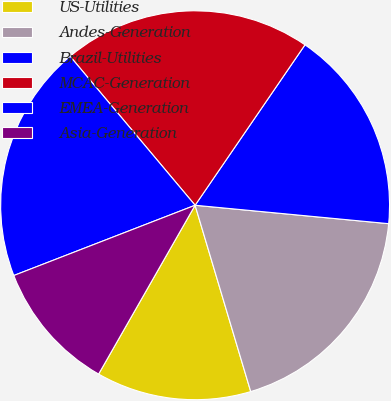Convert chart. <chart><loc_0><loc_0><loc_500><loc_500><pie_chart><fcel>US-Utilities<fcel>Andes-Generation<fcel>Brazil-Utilities<fcel>MCAC-Generation<fcel>EMEA-Generation<fcel>Asia-Generation<nl><fcel>12.88%<fcel>18.87%<fcel>16.95%<fcel>20.67%<fcel>19.77%<fcel>10.85%<nl></chart> 